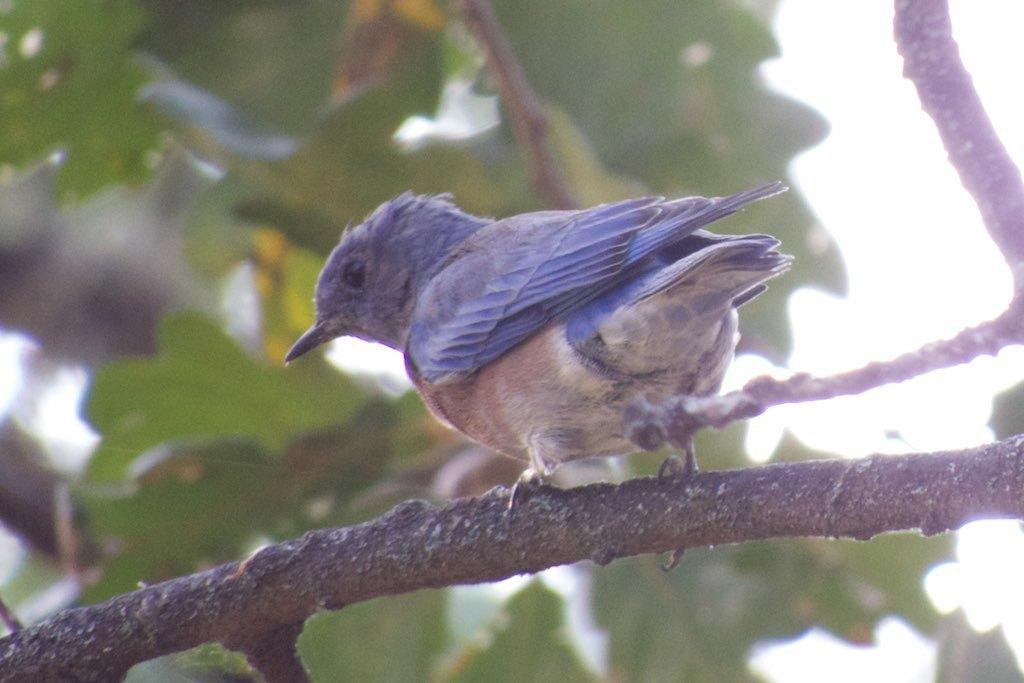In one or two sentences, can you explain what this image depicts? In the middle of the image a bird is standing on the stem. Behind the bird there are some trees and sky. 